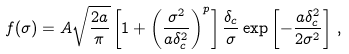Convert formula to latex. <formula><loc_0><loc_0><loc_500><loc_500>f ( \sigma ) = A \sqrt { \frac { 2 a } { \pi } } \left [ 1 + \left ( \frac { \sigma ^ { 2 } } { a \delta _ { c } ^ { 2 } } \right ) ^ { p } \right ] \frac { \delta _ { c } } { \sigma } \exp \left [ - \frac { a \delta _ { c } ^ { 2 } } { 2 \sigma ^ { 2 } } \right ] \, ,</formula> 